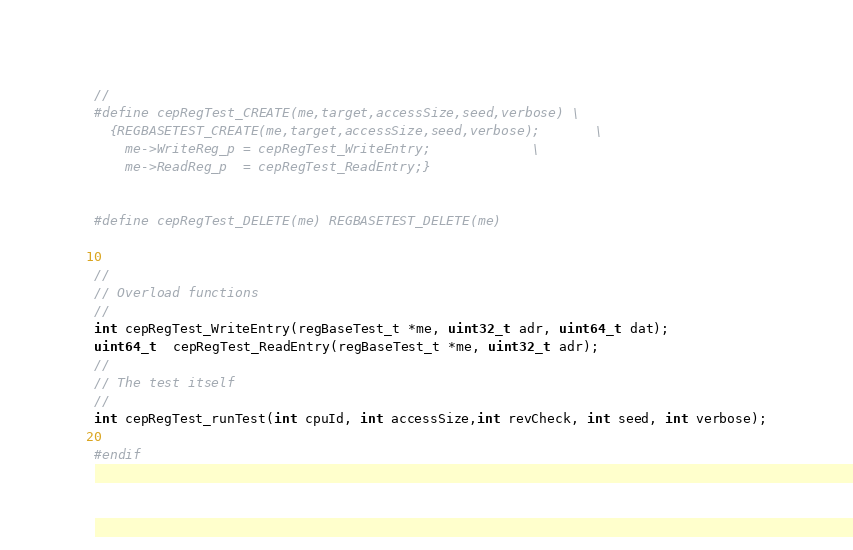<code> <loc_0><loc_0><loc_500><loc_500><_C_>//
#define cepRegTest_CREATE(me,target,accessSize,seed,verbose)	\
  {REGBASETEST_CREATE(me,target,accessSize,seed,verbose);		\
    me->WriteReg_p = cepRegTest_WriteEntry;				\
    me->ReadReg_p  = cepRegTest_ReadEntry;}


#define cepRegTest_DELETE(me) REGBASETEST_DELETE(me)


//
// Overload functions
//
int cepRegTest_WriteEntry(regBaseTest_t *me, uint32_t adr, uint64_t dat);
uint64_t  cepRegTest_ReadEntry(regBaseTest_t *me, uint32_t adr);
//
// The test itself
//
int cepRegTest_runTest(int cpuId, int accessSize,int revCheck, int seed, int verbose);

#endif
</code> 